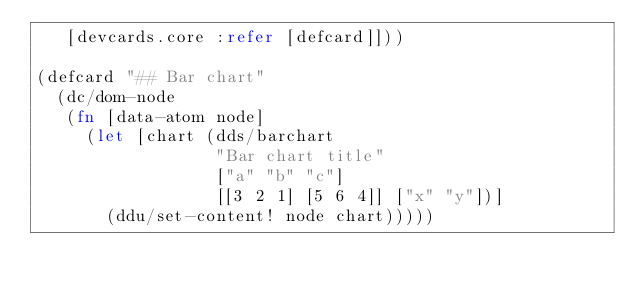Convert code to text. <code><loc_0><loc_0><loc_500><loc_500><_Clojure_>   [devcards.core :refer [defcard]]))

(defcard "## Bar chart"
  (dc/dom-node
   (fn [data-atom node]
     (let [chart (dds/barchart
                  "Bar chart title"
                  ["a" "b" "c"]
                  [[3 2 1] [5 6 4]] ["x" "y"])]
       (ddu/set-content! node chart)))))
</code> 